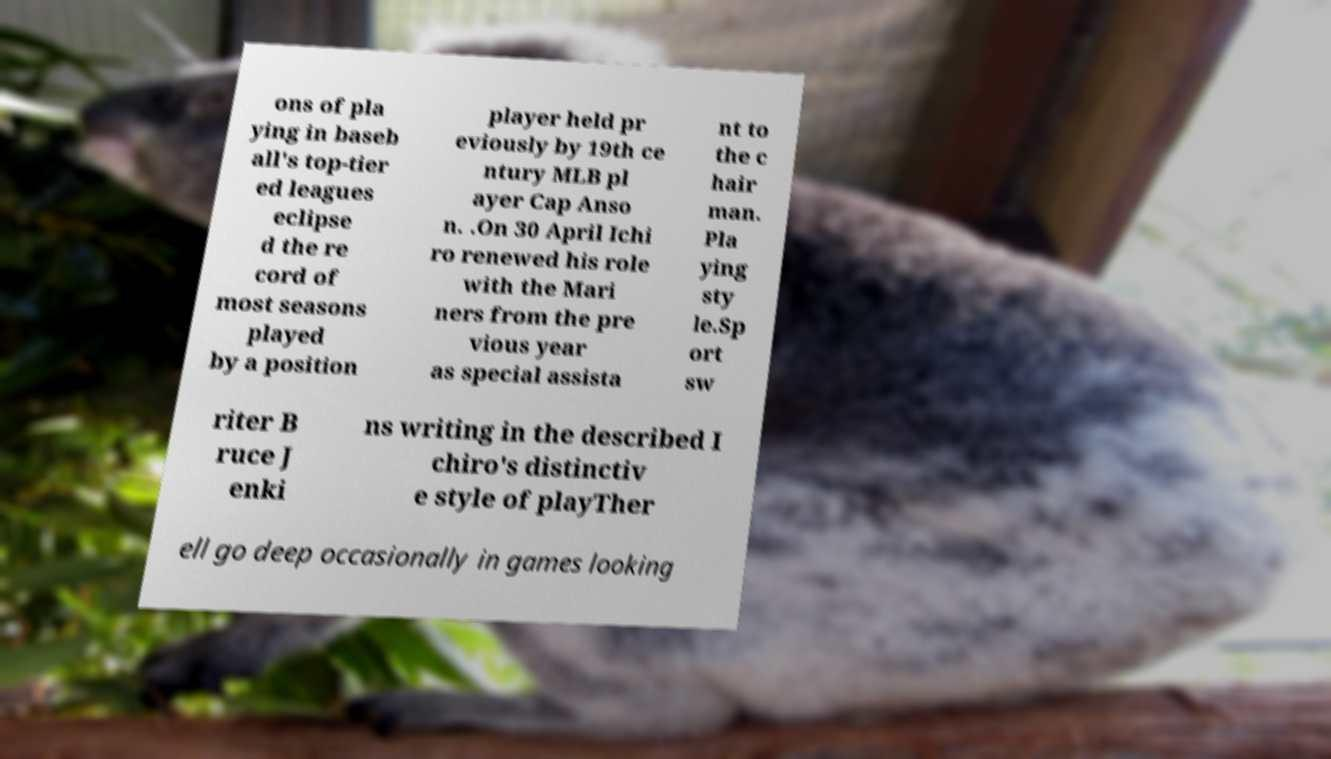For documentation purposes, I need the text within this image transcribed. Could you provide that? ons of pla ying in baseb all's top-tier ed leagues eclipse d the re cord of most seasons played by a position player held pr eviously by 19th ce ntury MLB pl ayer Cap Anso n. .On 30 April Ichi ro renewed his role with the Mari ners from the pre vious year as special assista nt to the c hair man. Pla ying sty le.Sp ort sw riter B ruce J enki ns writing in the described I chiro's distinctiv e style of playTher ell go deep occasionally in games looking 